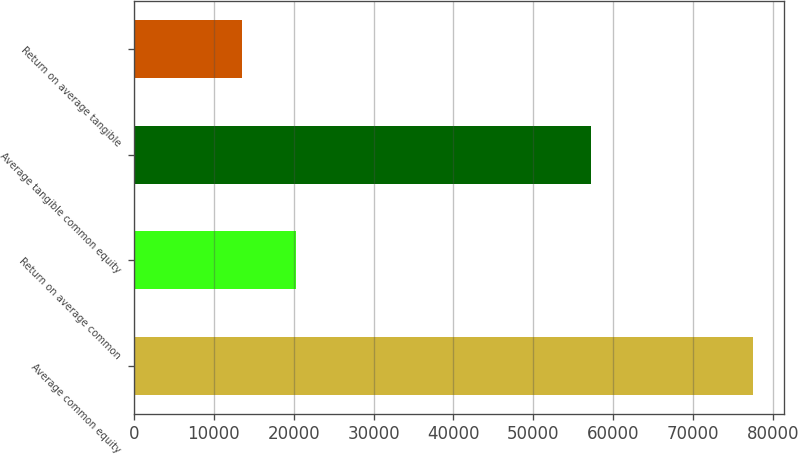<chart> <loc_0><loc_0><loc_500><loc_500><bar_chart><fcel>Average common equity<fcel>Return on average common<fcel>Average tangible common equity<fcel>Return on average tangible<nl><fcel>77544.8<fcel>20276.8<fcel>57275<fcel>13520.2<nl></chart> 